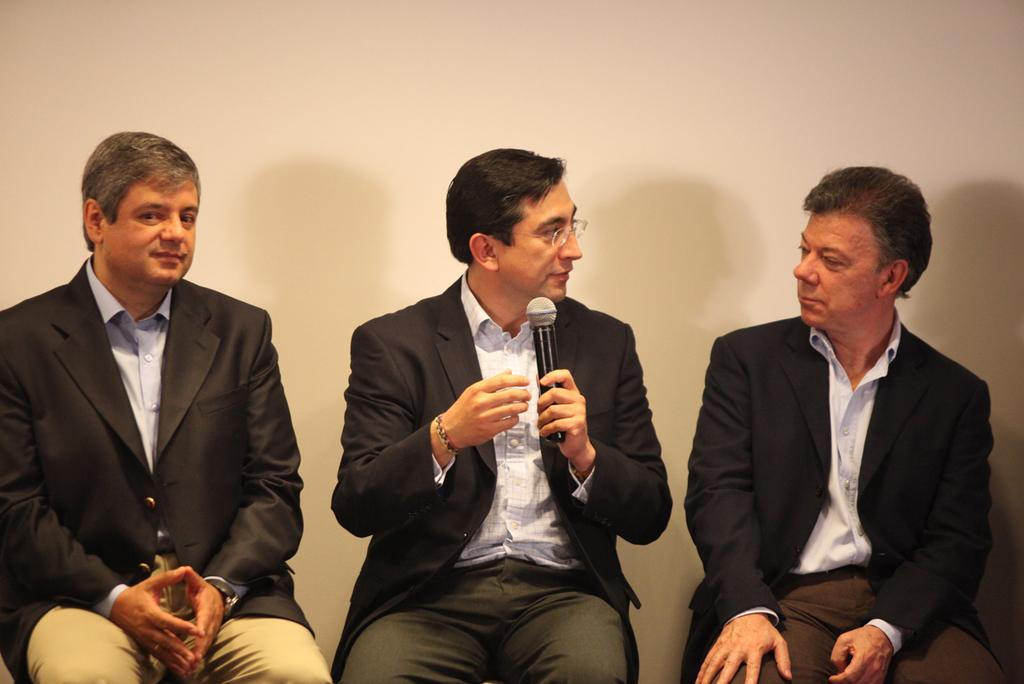How many people are in the image? There are three men in the image. What are the men doing in the image? The men are sitting. Can you describe the man in the center? The man in the center is holding a microphone. What is visible behind the men? There is a wall behind the men. What type of crate is being used by the men in the image? There is no crate present in the image. What color are the sisters' underwear in the image? There are no sisters or underwear present in the image. 